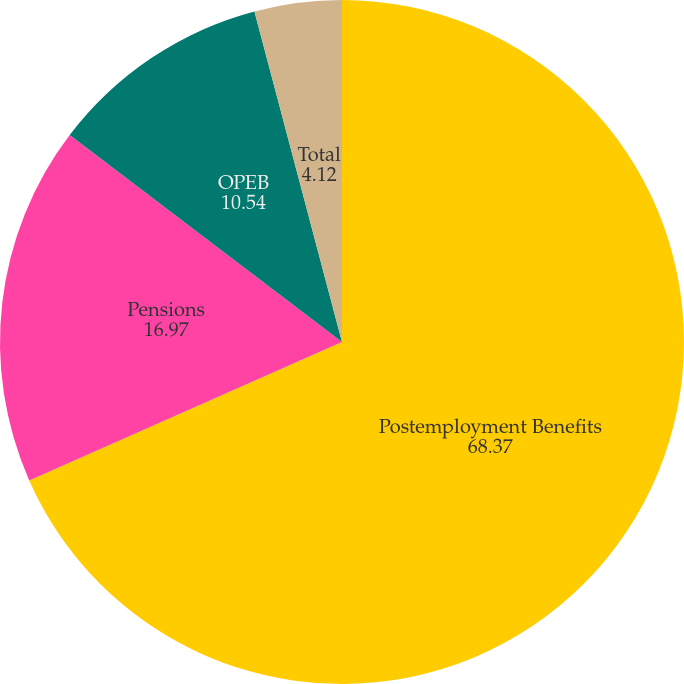Convert chart to OTSL. <chart><loc_0><loc_0><loc_500><loc_500><pie_chart><fcel>Postemployment Benefits<fcel>Pensions<fcel>OPEB<fcel>Total<nl><fcel>68.37%<fcel>16.97%<fcel>10.54%<fcel>4.12%<nl></chart> 